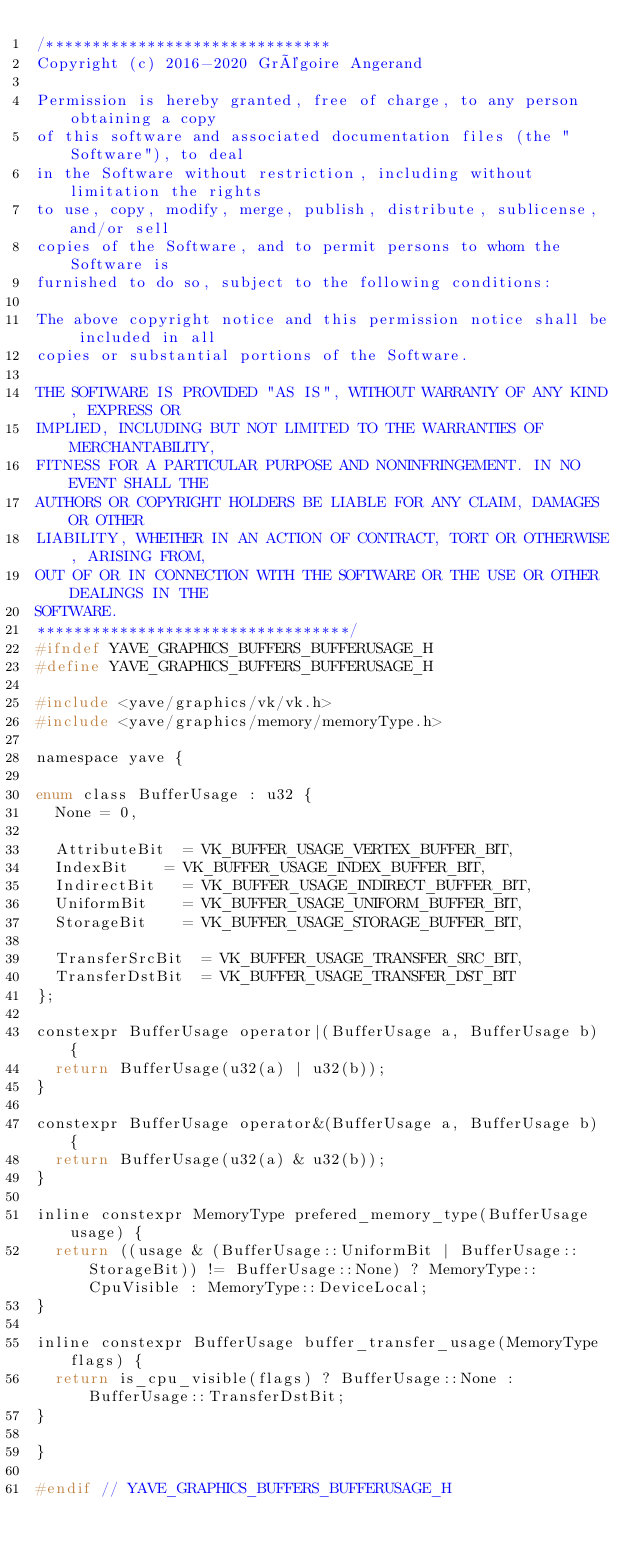<code> <loc_0><loc_0><loc_500><loc_500><_C_>/*******************************
Copyright (c) 2016-2020 Grégoire Angerand

Permission is hereby granted, free of charge, to any person obtaining a copy
of this software and associated documentation files (the "Software"), to deal
in the Software without restriction, including without limitation the rights
to use, copy, modify, merge, publish, distribute, sublicense, and/or sell
copies of the Software, and to permit persons to whom the Software is
furnished to do so, subject to the following conditions:

The above copyright notice and this permission notice shall be included in all
copies or substantial portions of the Software.

THE SOFTWARE IS PROVIDED "AS IS", WITHOUT WARRANTY OF ANY KIND, EXPRESS OR
IMPLIED, INCLUDING BUT NOT LIMITED TO THE WARRANTIES OF MERCHANTABILITY,
FITNESS FOR A PARTICULAR PURPOSE AND NONINFRINGEMENT. IN NO EVENT SHALL THE
AUTHORS OR COPYRIGHT HOLDERS BE LIABLE FOR ANY CLAIM, DAMAGES OR OTHER
LIABILITY, WHETHER IN AN ACTION OF CONTRACT, TORT OR OTHERWISE, ARISING FROM,
OUT OF OR IN CONNECTION WITH THE SOFTWARE OR THE USE OR OTHER DEALINGS IN THE
SOFTWARE.
**********************************/
#ifndef YAVE_GRAPHICS_BUFFERS_BUFFERUSAGE_H
#define YAVE_GRAPHICS_BUFFERS_BUFFERUSAGE_H

#include <yave/graphics/vk/vk.h>
#include <yave/graphics/memory/memoryType.h>

namespace yave {

enum class BufferUsage : u32 {
	None = 0,

	AttributeBit	= VK_BUFFER_USAGE_VERTEX_BUFFER_BIT,
	IndexBit		= VK_BUFFER_USAGE_INDEX_BUFFER_BIT,
	IndirectBit		= VK_BUFFER_USAGE_INDIRECT_BUFFER_BIT,
	UniformBit		= VK_BUFFER_USAGE_UNIFORM_BUFFER_BIT,
	StorageBit		= VK_BUFFER_USAGE_STORAGE_BUFFER_BIT,

	TransferSrcBit	= VK_BUFFER_USAGE_TRANSFER_SRC_BIT,
	TransferDstBit	= VK_BUFFER_USAGE_TRANSFER_DST_BIT
};

constexpr BufferUsage operator|(BufferUsage a, BufferUsage b) {
	return BufferUsage(u32(a) | u32(b));
}

constexpr BufferUsage operator&(BufferUsage a, BufferUsage b) {
	return BufferUsage(u32(a) & u32(b));
}

inline constexpr MemoryType prefered_memory_type(BufferUsage usage) {
	return ((usage & (BufferUsage::UniformBit | BufferUsage::StorageBit)) != BufferUsage::None) ? MemoryType::CpuVisible : MemoryType::DeviceLocal;
}

inline constexpr BufferUsage buffer_transfer_usage(MemoryType flags) {
	return is_cpu_visible(flags) ? BufferUsage::None : BufferUsage::TransferDstBit;
}

}

#endif // YAVE_GRAPHICS_BUFFERS_BUFFERUSAGE_H
</code> 